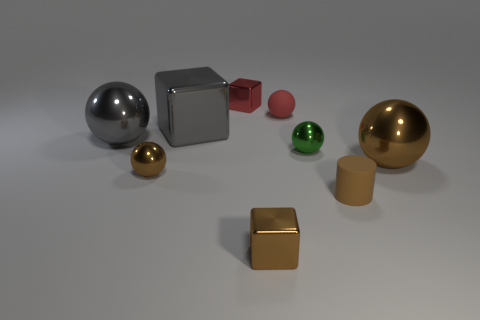There is a cube that is the same size as the gray metal sphere; what color is it?
Your response must be concise. Gray. Is the number of small red matte objects that are right of the tiny brown metal ball less than the number of objects that are behind the tiny red matte object?
Your response must be concise. No. There is a block that is both in front of the red rubber ball and behind the green ball; what material is it made of?
Provide a short and direct response. Metal. What material is the tiny sphere left of the rubber object that is behind the large sphere that is right of the small red metal cube made of?
Provide a succinct answer. Metal. Is the gray cube the same size as the gray metallic ball?
Provide a succinct answer. Yes. Is the color of the tiny matte ball the same as the thing behind the small red ball?
Keep it short and to the point. Yes. The thing that is made of the same material as the small red sphere is what shape?
Keep it short and to the point. Cylinder. Is the shape of the brown object that is on the right side of the brown matte cylinder the same as  the red matte thing?
Provide a succinct answer. Yes. There is a tiny ball that is the same material as the brown cylinder; what is its color?
Provide a succinct answer. Red. How many shiny cubes have the same size as the gray ball?
Give a very brief answer. 1. 